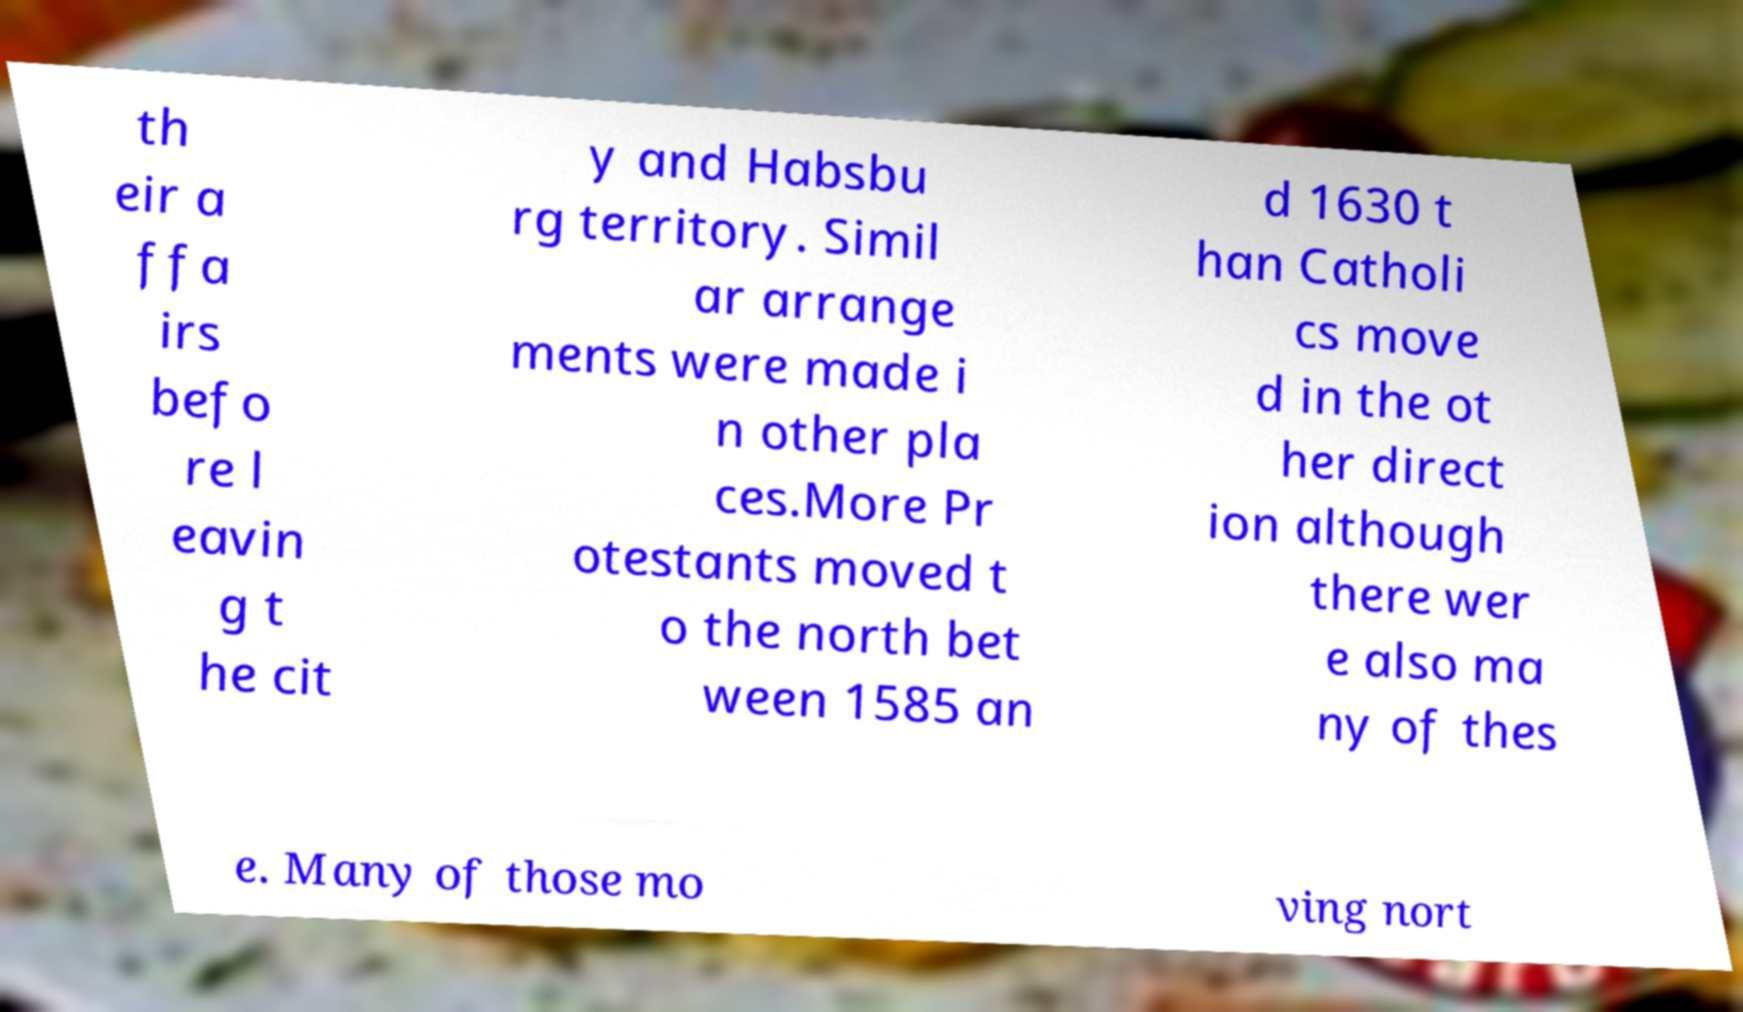Can you accurately transcribe the text from the provided image for me? th eir a ffa irs befo re l eavin g t he cit y and Habsbu rg territory. Simil ar arrange ments were made i n other pla ces.More Pr otestants moved t o the north bet ween 1585 an d 1630 t han Catholi cs move d in the ot her direct ion although there wer e also ma ny of thes e. Many of those mo ving nort 